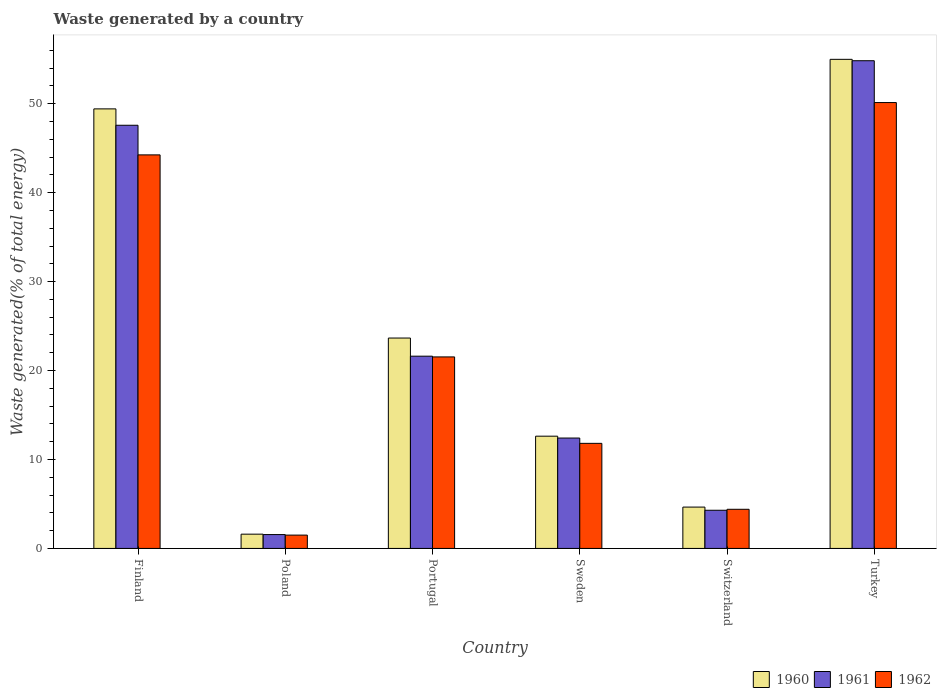How many groups of bars are there?
Keep it short and to the point. 6. Are the number of bars per tick equal to the number of legend labels?
Offer a terse response. Yes. What is the total waste generated in 1960 in Portugal?
Offer a terse response. 23.66. Across all countries, what is the maximum total waste generated in 1960?
Offer a very short reply. 54.99. Across all countries, what is the minimum total waste generated in 1961?
Your answer should be very brief. 1.56. What is the total total waste generated in 1960 in the graph?
Ensure brevity in your answer.  146.95. What is the difference between the total waste generated in 1960 in Sweden and that in Turkey?
Keep it short and to the point. -42.37. What is the difference between the total waste generated in 1961 in Poland and the total waste generated in 1962 in Sweden?
Ensure brevity in your answer.  -10.26. What is the average total waste generated in 1961 per country?
Your answer should be compact. 23.72. What is the difference between the total waste generated of/in 1960 and total waste generated of/in 1962 in Poland?
Offer a very short reply. 0.11. What is the ratio of the total waste generated in 1962 in Poland to that in Portugal?
Provide a short and direct response. 0.07. Is the total waste generated in 1962 in Sweden less than that in Switzerland?
Provide a short and direct response. No. Is the difference between the total waste generated in 1960 in Sweden and Switzerland greater than the difference between the total waste generated in 1962 in Sweden and Switzerland?
Your response must be concise. Yes. What is the difference between the highest and the second highest total waste generated in 1960?
Your response must be concise. -5.57. What is the difference between the highest and the lowest total waste generated in 1962?
Ensure brevity in your answer.  48.64. In how many countries, is the total waste generated in 1962 greater than the average total waste generated in 1962 taken over all countries?
Make the answer very short. 2. What does the 1st bar from the left in Switzerland represents?
Your answer should be compact. 1960. How many bars are there?
Offer a terse response. 18. How many countries are there in the graph?
Provide a succinct answer. 6. Does the graph contain grids?
Provide a succinct answer. No. Where does the legend appear in the graph?
Your answer should be very brief. Bottom right. How many legend labels are there?
Keep it short and to the point. 3. How are the legend labels stacked?
Keep it short and to the point. Horizontal. What is the title of the graph?
Offer a very short reply. Waste generated by a country. What is the label or title of the X-axis?
Your response must be concise. Country. What is the label or title of the Y-axis?
Your answer should be very brief. Waste generated(% of total energy). What is the Waste generated(% of total energy) in 1960 in Finland?
Keep it short and to the point. 49.42. What is the Waste generated(% of total energy) of 1961 in Finland?
Provide a short and direct response. 47.58. What is the Waste generated(% of total energy) in 1962 in Finland?
Offer a very short reply. 44.25. What is the Waste generated(% of total energy) of 1960 in Poland?
Your answer should be very brief. 1.6. What is the Waste generated(% of total energy) in 1961 in Poland?
Provide a short and direct response. 1.56. What is the Waste generated(% of total energy) of 1962 in Poland?
Your response must be concise. 1.5. What is the Waste generated(% of total energy) of 1960 in Portugal?
Give a very brief answer. 23.66. What is the Waste generated(% of total energy) in 1961 in Portugal?
Keep it short and to the point. 21.62. What is the Waste generated(% of total energy) in 1962 in Portugal?
Your answer should be compact. 21.53. What is the Waste generated(% of total energy) of 1960 in Sweden?
Provide a succinct answer. 12.62. What is the Waste generated(% of total energy) in 1961 in Sweden?
Give a very brief answer. 12.41. What is the Waste generated(% of total energy) in 1962 in Sweden?
Ensure brevity in your answer.  11.82. What is the Waste generated(% of total energy) of 1960 in Switzerland?
Provide a short and direct response. 4.65. What is the Waste generated(% of total energy) in 1961 in Switzerland?
Your response must be concise. 4.29. What is the Waste generated(% of total energy) of 1962 in Switzerland?
Provide a short and direct response. 4.4. What is the Waste generated(% of total energy) in 1960 in Turkey?
Provide a short and direct response. 54.99. What is the Waste generated(% of total energy) of 1961 in Turkey?
Give a very brief answer. 54.84. What is the Waste generated(% of total energy) in 1962 in Turkey?
Offer a very short reply. 50.13. Across all countries, what is the maximum Waste generated(% of total energy) of 1960?
Give a very brief answer. 54.99. Across all countries, what is the maximum Waste generated(% of total energy) in 1961?
Ensure brevity in your answer.  54.84. Across all countries, what is the maximum Waste generated(% of total energy) in 1962?
Provide a short and direct response. 50.13. Across all countries, what is the minimum Waste generated(% of total energy) of 1960?
Your answer should be very brief. 1.6. Across all countries, what is the minimum Waste generated(% of total energy) of 1961?
Your answer should be compact. 1.56. Across all countries, what is the minimum Waste generated(% of total energy) of 1962?
Make the answer very short. 1.5. What is the total Waste generated(% of total energy) in 1960 in the graph?
Your response must be concise. 146.95. What is the total Waste generated(% of total energy) in 1961 in the graph?
Provide a short and direct response. 142.3. What is the total Waste generated(% of total energy) in 1962 in the graph?
Ensure brevity in your answer.  133.64. What is the difference between the Waste generated(% of total energy) in 1960 in Finland and that in Poland?
Provide a succinct answer. 47.82. What is the difference between the Waste generated(% of total energy) in 1961 in Finland and that in Poland?
Your response must be concise. 46.02. What is the difference between the Waste generated(% of total energy) in 1962 in Finland and that in Poland?
Provide a succinct answer. 42.75. What is the difference between the Waste generated(% of total energy) of 1960 in Finland and that in Portugal?
Your answer should be very brief. 25.77. What is the difference between the Waste generated(% of total energy) in 1961 in Finland and that in Portugal?
Your response must be concise. 25.96. What is the difference between the Waste generated(% of total energy) in 1962 in Finland and that in Portugal?
Provide a short and direct response. 22.72. What is the difference between the Waste generated(% of total energy) of 1960 in Finland and that in Sweden?
Your response must be concise. 36.8. What is the difference between the Waste generated(% of total energy) in 1961 in Finland and that in Sweden?
Make the answer very short. 35.17. What is the difference between the Waste generated(% of total energy) in 1962 in Finland and that in Sweden?
Keep it short and to the point. 32.44. What is the difference between the Waste generated(% of total energy) of 1960 in Finland and that in Switzerland?
Give a very brief answer. 44.77. What is the difference between the Waste generated(% of total energy) of 1961 in Finland and that in Switzerland?
Give a very brief answer. 43.29. What is the difference between the Waste generated(% of total energy) of 1962 in Finland and that in Switzerland?
Ensure brevity in your answer.  39.85. What is the difference between the Waste generated(% of total energy) in 1960 in Finland and that in Turkey?
Keep it short and to the point. -5.57. What is the difference between the Waste generated(% of total energy) of 1961 in Finland and that in Turkey?
Your answer should be very brief. -7.26. What is the difference between the Waste generated(% of total energy) of 1962 in Finland and that in Turkey?
Offer a terse response. -5.88. What is the difference between the Waste generated(% of total energy) in 1960 in Poland and that in Portugal?
Your response must be concise. -22.05. What is the difference between the Waste generated(% of total energy) of 1961 in Poland and that in Portugal?
Give a very brief answer. -20.06. What is the difference between the Waste generated(% of total energy) of 1962 in Poland and that in Portugal?
Your answer should be very brief. -20.03. What is the difference between the Waste generated(% of total energy) in 1960 in Poland and that in Sweden?
Keep it short and to the point. -11.02. What is the difference between the Waste generated(% of total energy) in 1961 in Poland and that in Sweden?
Give a very brief answer. -10.85. What is the difference between the Waste generated(% of total energy) of 1962 in Poland and that in Sweden?
Offer a very short reply. -10.32. What is the difference between the Waste generated(% of total energy) of 1960 in Poland and that in Switzerland?
Offer a very short reply. -3.04. What is the difference between the Waste generated(% of total energy) in 1961 in Poland and that in Switzerland?
Provide a short and direct response. -2.73. What is the difference between the Waste generated(% of total energy) in 1962 in Poland and that in Switzerland?
Give a very brief answer. -2.9. What is the difference between the Waste generated(% of total energy) in 1960 in Poland and that in Turkey?
Keep it short and to the point. -53.39. What is the difference between the Waste generated(% of total energy) in 1961 in Poland and that in Turkey?
Your answer should be compact. -53.28. What is the difference between the Waste generated(% of total energy) in 1962 in Poland and that in Turkey?
Your answer should be very brief. -48.64. What is the difference between the Waste generated(% of total energy) of 1960 in Portugal and that in Sweden?
Offer a terse response. 11.03. What is the difference between the Waste generated(% of total energy) of 1961 in Portugal and that in Sweden?
Your answer should be very brief. 9.2. What is the difference between the Waste generated(% of total energy) of 1962 in Portugal and that in Sweden?
Give a very brief answer. 9.72. What is the difference between the Waste generated(% of total energy) of 1960 in Portugal and that in Switzerland?
Your answer should be compact. 19.01. What is the difference between the Waste generated(% of total energy) of 1961 in Portugal and that in Switzerland?
Make the answer very short. 17.32. What is the difference between the Waste generated(% of total energy) of 1962 in Portugal and that in Switzerland?
Provide a succinct answer. 17.13. What is the difference between the Waste generated(% of total energy) in 1960 in Portugal and that in Turkey?
Offer a terse response. -31.34. What is the difference between the Waste generated(% of total energy) in 1961 in Portugal and that in Turkey?
Provide a short and direct response. -33.22. What is the difference between the Waste generated(% of total energy) in 1962 in Portugal and that in Turkey?
Your answer should be compact. -28.6. What is the difference between the Waste generated(% of total energy) in 1960 in Sweden and that in Switzerland?
Offer a very short reply. 7.97. What is the difference between the Waste generated(% of total energy) in 1961 in Sweden and that in Switzerland?
Make the answer very short. 8.12. What is the difference between the Waste generated(% of total energy) of 1962 in Sweden and that in Switzerland?
Give a very brief answer. 7.41. What is the difference between the Waste generated(% of total energy) of 1960 in Sweden and that in Turkey?
Keep it short and to the point. -42.37. What is the difference between the Waste generated(% of total energy) in 1961 in Sweden and that in Turkey?
Keep it short and to the point. -42.43. What is the difference between the Waste generated(% of total energy) in 1962 in Sweden and that in Turkey?
Provide a short and direct response. -38.32. What is the difference between the Waste generated(% of total energy) in 1960 in Switzerland and that in Turkey?
Your response must be concise. -50.34. What is the difference between the Waste generated(% of total energy) of 1961 in Switzerland and that in Turkey?
Your answer should be compact. -50.55. What is the difference between the Waste generated(% of total energy) of 1962 in Switzerland and that in Turkey?
Ensure brevity in your answer.  -45.73. What is the difference between the Waste generated(% of total energy) in 1960 in Finland and the Waste generated(% of total energy) in 1961 in Poland?
Offer a terse response. 47.86. What is the difference between the Waste generated(% of total energy) in 1960 in Finland and the Waste generated(% of total energy) in 1962 in Poland?
Give a very brief answer. 47.92. What is the difference between the Waste generated(% of total energy) in 1961 in Finland and the Waste generated(% of total energy) in 1962 in Poland?
Give a very brief answer. 46.08. What is the difference between the Waste generated(% of total energy) in 1960 in Finland and the Waste generated(% of total energy) in 1961 in Portugal?
Keep it short and to the point. 27.81. What is the difference between the Waste generated(% of total energy) in 1960 in Finland and the Waste generated(% of total energy) in 1962 in Portugal?
Provide a succinct answer. 27.89. What is the difference between the Waste generated(% of total energy) of 1961 in Finland and the Waste generated(% of total energy) of 1962 in Portugal?
Your answer should be compact. 26.05. What is the difference between the Waste generated(% of total energy) of 1960 in Finland and the Waste generated(% of total energy) of 1961 in Sweden?
Offer a terse response. 37.01. What is the difference between the Waste generated(% of total energy) in 1960 in Finland and the Waste generated(% of total energy) in 1962 in Sweden?
Your response must be concise. 37.61. What is the difference between the Waste generated(% of total energy) in 1961 in Finland and the Waste generated(% of total energy) in 1962 in Sweden?
Ensure brevity in your answer.  35.77. What is the difference between the Waste generated(% of total energy) in 1960 in Finland and the Waste generated(% of total energy) in 1961 in Switzerland?
Provide a succinct answer. 45.13. What is the difference between the Waste generated(% of total energy) in 1960 in Finland and the Waste generated(% of total energy) in 1962 in Switzerland?
Give a very brief answer. 45.02. What is the difference between the Waste generated(% of total energy) of 1961 in Finland and the Waste generated(% of total energy) of 1962 in Switzerland?
Provide a succinct answer. 43.18. What is the difference between the Waste generated(% of total energy) of 1960 in Finland and the Waste generated(% of total energy) of 1961 in Turkey?
Provide a succinct answer. -5.42. What is the difference between the Waste generated(% of total energy) in 1960 in Finland and the Waste generated(% of total energy) in 1962 in Turkey?
Offer a very short reply. -0.71. What is the difference between the Waste generated(% of total energy) of 1961 in Finland and the Waste generated(% of total energy) of 1962 in Turkey?
Provide a succinct answer. -2.55. What is the difference between the Waste generated(% of total energy) in 1960 in Poland and the Waste generated(% of total energy) in 1961 in Portugal?
Offer a terse response. -20.01. What is the difference between the Waste generated(% of total energy) of 1960 in Poland and the Waste generated(% of total energy) of 1962 in Portugal?
Offer a very short reply. -19.93. What is the difference between the Waste generated(% of total energy) in 1961 in Poland and the Waste generated(% of total energy) in 1962 in Portugal?
Your answer should be compact. -19.98. What is the difference between the Waste generated(% of total energy) of 1960 in Poland and the Waste generated(% of total energy) of 1961 in Sweden?
Give a very brief answer. -10.81. What is the difference between the Waste generated(% of total energy) in 1960 in Poland and the Waste generated(% of total energy) in 1962 in Sweden?
Give a very brief answer. -10.21. What is the difference between the Waste generated(% of total energy) of 1961 in Poland and the Waste generated(% of total energy) of 1962 in Sweden?
Make the answer very short. -10.26. What is the difference between the Waste generated(% of total energy) in 1960 in Poland and the Waste generated(% of total energy) in 1961 in Switzerland?
Keep it short and to the point. -2.69. What is the difference between the Waste generated(% of total energy) of 1960 in Poland and the Waste generated(% of total energy) of 1962 in Switzerland?
Offer a terse response. -2.8. What is the difference between the Waste generated(% of total energy) of 1961 in Poland and the Waste generated(% of total energy) of 1962 in Switzerland?
Ensure brevity in your answer.  -2.84. What is the difference between the Waste generated(% of total energy) in 1960 in Poland and the Waste generated(% of total energy) in 1961 in Turkey?
Give a very brief answer. -53.23. What is the difference between the Waste generated(% of total energy) in 1960 in Poland and the Waste generated(% of total energy) in 1962 in Turkey?
Provide a succinct answer. -48.53. What is the difference between the Waste generated(% of total energy) in 1961 in Poland and the Waste generated(% of total energy) in 1962 in Turkey?
Provide a succinct answer. -48.58. What is the difference between the Waste generated(% of total energy) of 1960 in Portugal and the Waste generated(% of total energy) of 1961 in Sweden?
Your answer should be very brief. 11.24. What is the difference between the Waste generated(% of total energy) in 1960 in Portugal and the Waste generated(% of total energy) in 1962 in Sweden?
Provide a succinct answer. 11.84. What is the difference between the Waste generated(% of total energy) of 1961 in Portugal and the Waste generated(% of total energy) of 1962 in Sweden?
Offer a very short reply. 9.8. What is the difference between the Waste generated(% of total energy) of 1960 in Portugal and the Waste generated(% of total energy) of 1961 in Switzerland?
Keep it short and to the point. 19.36. What is the difference between the Waste generated(% of total energy) of 1960 in Portugal and the Waste generated(% of total energy) of 1962 in Switzerland?
Ensure brevity in your answer.  19.25. What is the difference between the Waste generated(% of total energy) in 1961 in Portugal and the Waste generated(% of total energy) in 1962 in Switzerland?
Your answer should be compact. 17.21. What is the difference between the Waste generated(% of total energy) of 1960 in Portugal and the Waste generated(% of total energy) of 1961 in Turkey?
Provide a short and direct response. -31.18. What is the difference between the Waste generated(% of total energy) of 1960 in Portugal and the Waste generated(% of total energy) of 1962 in Turkey?
Ensure brevity in your answer.  -26.48. What is the difference between the Waste generated(% of total energy) in 1961 in Portugal and the Waste generated(% of total energy) in 1962 in Turkey?
Your answer should be compact. -28.52. What is the difference between the Waste generated(% of total energy) in 1960 in Sweden and the Waste generated(% of total energy) in 1961 in Switzerland?
Ensure brevity in your answer.  8.33. What is the difference between the Waste generated(% of total energy) of 1960 in Sweden and the Waste generated(% of total energy) of 1962 in Switzerland?
Make the answer very short. 8.22. What is the difference between the Waste generated(% of total energy) in 1961 in Sweden and the Waste generated(% of total energy) in 1962 in Switzerland?
Keep it short and to the point. 8.01. What is the difference between the Waste generated(% of total energy) of 1960 in Sweden and the Waste generated(% of total energy) of 1961 in Turkey?
Your answer should be very brief. -42.22. What is the difference between the Waste generated(% of total energy) of 1960 in Sweden and the Waste generated(% of total energy) of 1962 in Turkey?
Make the answer very short. -37.51. What is the difference between the Waste generated(% of total energy) in 1961 in Sweden and the Waste generated(% of total energy) in 1962 in Turkey?
Provide a succinct answer. -37.72. What is the difference between the Waste generated(% of total energy) of 1960 in Switzerland and the Waste generated(% of total energy) of 1961 in Turkey?
Provide a succinct answer. -50.19. What is the difference between the Waste generated(% of total energy) in 1960 in Switzerland and the Waste generated(% of total energy) in 1962 in Turkey?
Offer a very short reply. -45.48. What is the difference between the Waste generated(% of total energy) in 1961 in Switzerland and the Waste generated(% of total energy) in 1962 in Turkey?
Keep it short and to the point. -45.84. What is the average Waste generated(% of total energy) of 1960 per country?
Keep it short and to the point. 24.49. What is the average Waste generated(% of total energy) of 1961 per country?
Keep it short and to the point. 23.72. What is the average Waste generated(% of total energy) of 1962 per country?
Your answer should be very brief. 22.27. What is the difference between the Waste generated(% of total energy) in 1960 and Waste generated(% of total energy) in 1961 in Finland?
Your answer should be compact. 1.84. What is the difference between the Waste generated(% of total energy) in 1960 and Waste generated(% of total energy) in 1962 in Finland?
Give a very brief answer. 5.17. What is the difference between the Waste generated(% of total energy) of 1961 and Waste generated(% of total energy) of 1962 in Finland?
Your response must be concise. 3.33. What is the difference between the Waste generated(% of total energy) of 1960 and Waste generated(% of total energy) of 1961 in Poland?
Ensure brevity in your answer.  0.05. What is the difference between the Waste generated(% of total energy) of 1960 and Waste generated(% of total energy) of 1962 in Poland?
Offer a terse response. 0.11. What is the difference between the Waste generated(% of total energy) of 1961 and Waste generated(% of total energy) of 1962 in Poland?
Offer a very short reply. 0.06. What is the difference between the Waste generated(% of total energy) of 1960 and Waste generated(% of total energy) of 1961 in Portugal?
Offer a terse response. 2.04. What is the difference between the Waste generated(% of total energy) of 1960 and Waste generated(% of total energy) of 1962 in Portugal?
Ensure brevity in your answer.  2.12. What is the difference between the Waste generated(% of total energy) of 1961 and Waste generated(% of total energy) of 1962 in Portugal?
Keep it short and to the point. 0.08. What is the difference between the Waste generated(% of total energy) of 1960 and Waste generated(% of total energy) of 1961 in Sweden?
Provide a succinct answer. 0.21. What is the difference between the Waste generated(% of total energy) in 1960 and Waste generated(% of total energy) in 1962 in Sweden?
Provide a succinct answer. 0.81. What is the difference between the Waste generated(% of total energy) of 1961 and Waste generated(% of total energy) of 1962 in Sweden?
Keep it short and to the point. 0.6. What is the difference between the Waste generated(% of total energy) in 1960 and Waste generated(% of total energy) in 1961 in Switzerland?
Your answer should be compact. 0.36. What is the difference between the Waste generated(% of total energy) of 1960 and Waste generated(% of total energy) of 1962 in Switzerland?
Provide a succinct answer. 0.25. What is the difference between the Waste generated(% of total energy) of 1961 and Waste generated(% of total energy) of 1962 in Switzerland?
Your answer should be very brief. -0.11. What is the difference between the Waste generated(% of total energy) in 1960 and Waste generated(% of total energy) in 1961 in Turkey?
Provide a short and direct response. 0.16. What is the difference between the Waste generated(% of total energy) of 1960 and Waste generated(% of total energy) of 1962 in Turkey?
Your answer should be compact. 4.86. What is the difference between the Waste generated(% of total energy) of 1961 and Waste generated(% of total energy) of 1962 in Turkey?
Provide a succinct answer. 4.7. What is the ratio of the Waste generated(% of total energy) in 1960 in Finland to that in Poland?
Give a very brief answer. 30.8. What is the ratio of the Waste generated(% of total energy) of 1961 in Finland to that in Poland?
Your answer should be very brief. 30.53. What is the ratio of the Waste generated(% of total energy) of 1962 in Finland to that in Poland?
Make the answer very short. 29.52. What is the ratio of the Waste generated(% of total energy) of 1960 in Finland to that in Portugal?
Provide a short and direct response. 2.09. What is the ratio of the Waste generated(% of total energy) in 1961 in Finland to that in Portugal?
Offer a very short reply. 2.2. What is the ratio of the Waste generated(% of total energy) of 1962 in Finland to that in Portugal?
Offer a very short reply. 2.05. What is the ratio of the Waste generated(% of total energy) in 1960 in Finland to that in Sweden?
Offer a terse response. 3.92. What is the ratio of the Waste generated(% of total energy) of 1961 in Finland to that in Sweden?
Offer a terse response. 3.83. What is the ratio of the Waste generated(% of total energy) of 1962 in Finland to that in Sweden?
Offer a terse response. 3.75. What is the ratio of the Waste generated(% of total energy) of 1960 in Finland to that in Switzerland?
Keep it short and to the point. 10.63. What is the ratio of the Waste generated(% of total energy) in 1961 in Finland to that in Switzerland?
Your answer should be very brief. 11.09. What is the ratio of the Waste generated(% of total energy) of 1962 in Finland to that in Switzerland?
Offer a terse response. 10.05. What is the ratio of the Waste generated(% of total energy) of 1960 in Finland to that in Turkey?
Your answer should be very brief. 0.9. What is the ratio of the Waste generated(% of total energy) in 1961 in Finland to that in Turkey?
Keep it short and to the point. 0.87. What is the ratio of the Waste generated(% of total energy) in 1962 in Finland to that in Turkey?
Your answer should be very brief. 0.88. What is the ratio of the Waste generated(% of total energy) in 1960 in Poland to that in Portugal?
Your response must be concise. 0.07. What is the ratio of the Waste generated(% of total energy) in 1961 in Poland to that in Portugal?
Your answer should be compact. 0.07. What is the ratio of the Waste generated(% of total energy) of 1962 in Poland to that in Portugal?
Your answer should be compact. 0.07. What is the ratio of the Waste generated(% of total energy) of 1960 in Poland to that in Sweden?
Your response must be concise. 0.13. What is the ratio of the Waste generated(% of total energy) of 1961 in Poland to that in Sweden?
Your answer should be compact. 0.13. What is the ratio of the Waste generated(% of total energy) in 1962 in Poland to that in Sweden?
Your answer should be compact. 0.13. What is the ratio of the Waste generated(% of total energy) of 1960 in Poland to that in Switzerland?
Your answer should be compact. 0.35. What is the ratio of the Waste generated(% of total energy) of 1961 in Poland to that in Switzerland?
Provide a short and direct response. 0.36. What is the ratio of the Waste generated(% of total energy) in 1962 in Poland to that in Switzerland?
Your answer should be compact. 0.34. What is the ratio of the Waste generated(% of total energy) of 1960 in Poland to that in Turkey?
Your response must be concise. 0.03. What is the ratio of the Waste generated(% of total energy) of 1961 in Poland to that in Turkey?
Give a very brief answer. 0.03. What is the ratio of the Waste generated(% of total energy) of 1962 in Poland to that in Turkey?
Provide a short and direct response. 0.03. What is the ratio of the Waste generated(% of total energy) in 1960 in Portugal to that in Sweden?
Give a very brief answer. 1.87. What is the ratio of the Waste generated(% of total energy) of 1961 in Portugal to that in Sweden?
Your response must be concise. 1.74. What is the ratio of the Waste generated(% of total energy) in 1962 in Portugal to that in Sweden?
Your response must be concise. 1.82. What is the ratio of the Waste generated(% of total energy) of 1960 in Portugal to that in Switzerland?
Give a very brief answer. 5.09. What is the ratio of the Waste generated(% of total energy) of 1961 in Portugal to that in Switzerland?
Your response must be concise. 5.04. What is the ratio of the Waste generated(% of total energy) in 1962 in Portugal to that in Switzerland?
Keep it short and to the point. 4.89. What is the ratio of the Waste generated(% of total energy) in 1960 in Portugal to that in Turkey?
Make the answer very short. 0.43. What is the ratio of the Waste generated(% of total energy) in 1961 in Portugal to that in Turkey?
Offer a very short reply. 0.39. What is the ratio of the Waste generated(% of total energy) in 1962 in Portugal to that in Turkey?
Provide a succinct answer. 0.43. What is the ratio of the Waste generated(% of total energy) in 1960 in Sweden to that in Switzerland?
Offer a very short reply. 2.71. What is the ratio of the Waste generated(% of total energy) of 1961 in Sweden to that in Switzerland?
Your answer should be very brief. 2.89. What is the ratio of the Waste generated(% of total energy) in 1962 in Sweden to that in Switzerland?
Your answer should be very brief. 2.68. What is the ratio of the Waste generated(% of total energy) of 1960 in Sweden to that in Turkey?
Your answer should be very brief. 0.23. What is the ratio of the Waste generated(% of total energy) of 1961 in Sweden to that in Turkey?
Your answer should be very brief. 0.23. What is the ratio of the Waste generated(% of total energy) of 1962 in Sweden to that in Turkey?
Your answer should be very brief. 0.24. What is the ratio of the Waste generated(% of total energy) of 1960 in Switzerland to that in Turkey?
Give a very brief answer. 0.08. What is the ratio of the Waste generated(% of total energy) in 1961 in Switzerland to that in Turkey?
Make the answer very short. 0.08. What is the ratio of the Waste generated(% of total energy) in 1962 in Switzerland to that in Turkey?
Offer a terse response. 0.09. What is the difference between the highest and the second highest Waste generated(% of total energy) in 1960?
Offer a very short reply. 5.57. What is the difference between the highest and the second highest Waste generated(% of total energy) of 1961?
Provide a succinct answer. 7.26. What is the difference between the highest and the second highest Waste generated(% of total energy) of 1962?
Keep it short and to the point. 5.88. What is the difference between the highest and the lowest Waste generated(% of total energy) of 1960?
Provide a short and direct response. 53.39. What is the difference between the highest and the lowest Waste generated(% of total energy) in 1961?
Keep it short and to the point. 53.28. What is the difference between the highest and the lowest Waste generated(% of total energy) in 1962?
Your answer should be compact. 48.64. 